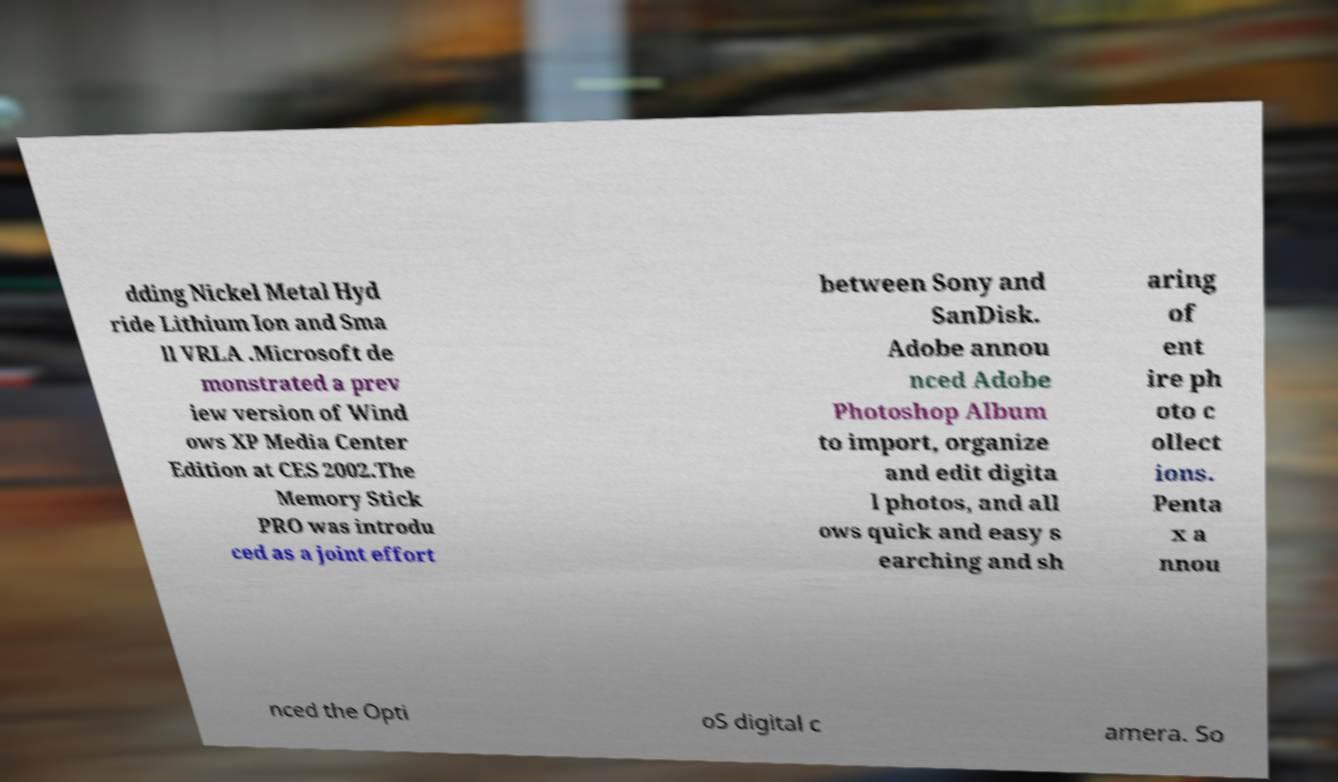Could you assist in decoding the text presented in this image and type it out clearly? dding Nickel Metal Hyd ride Lithium Ion and Sma ll VRLA .Microsoft de monstrated a prev iew version of Wind ows XP Media Center Edition at CES 2002.The Memory Stick PRO was introdu ced as a joint effort between Sony and SanDisk. Adobe annou nced Adobe Photoshop Album to import, organize and edit digita l photos, and all ows quick and easy s earching and sh aring of ent ire ph oto c ollect ions. Penta x a nnou nced the Opti oS digital c amera. So 